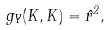Convert formula to latex. <formula><loc_0><loc_0><loc_500><loc_500>g _ { Y } ( K , K ) = \hat { r } ^ { 2 } ,</formula> 